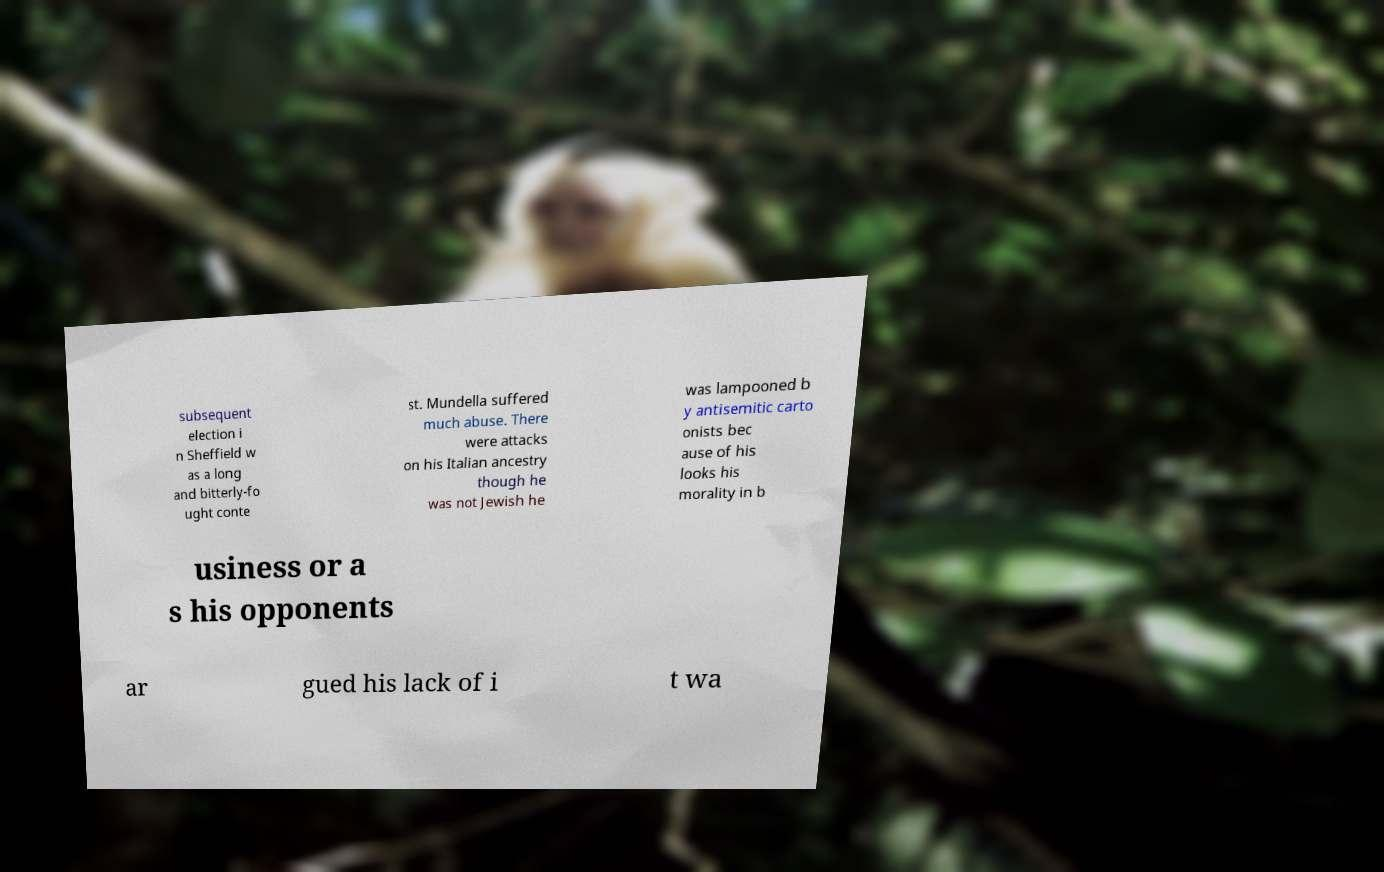Can you accurately transcribe the text from the provided image for me? subsequent election i n Sheffield w as a long and bitterly-fo ught conte st. Mundella suffered much abuse. There were attacks on his Italian ancestry though he was not Jewish he was lampooned b y antisemitic carto onists bec ause of his looks his morality in b usiness or a s his opponents ar gued his lack of i t wa 